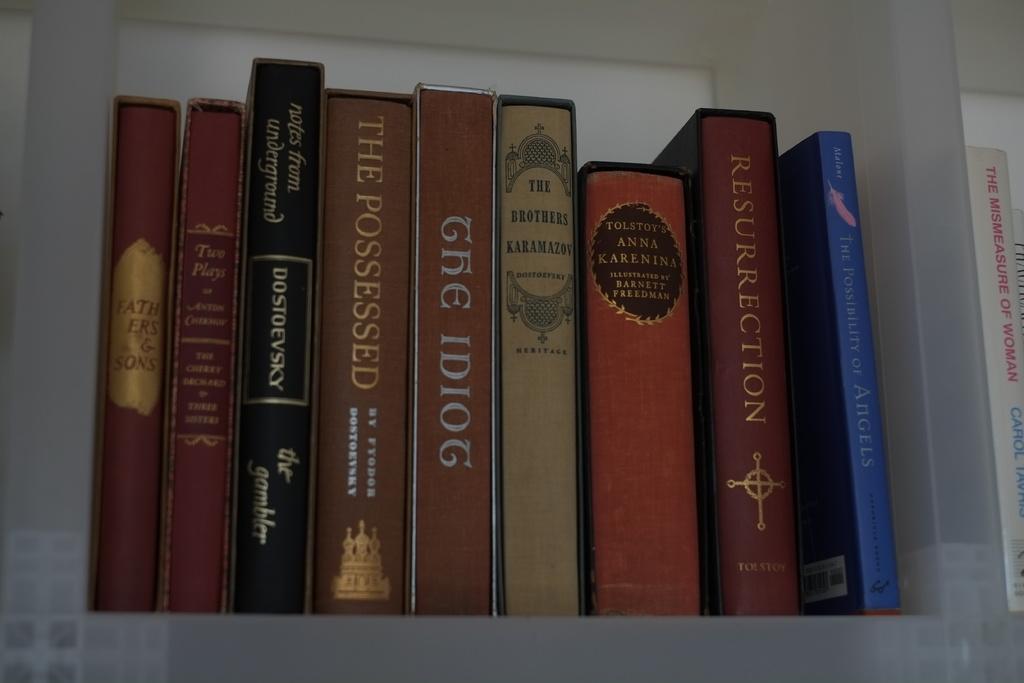Is this a blue book?
Your answer should be very brief. Answering does not require reading text in the image. 